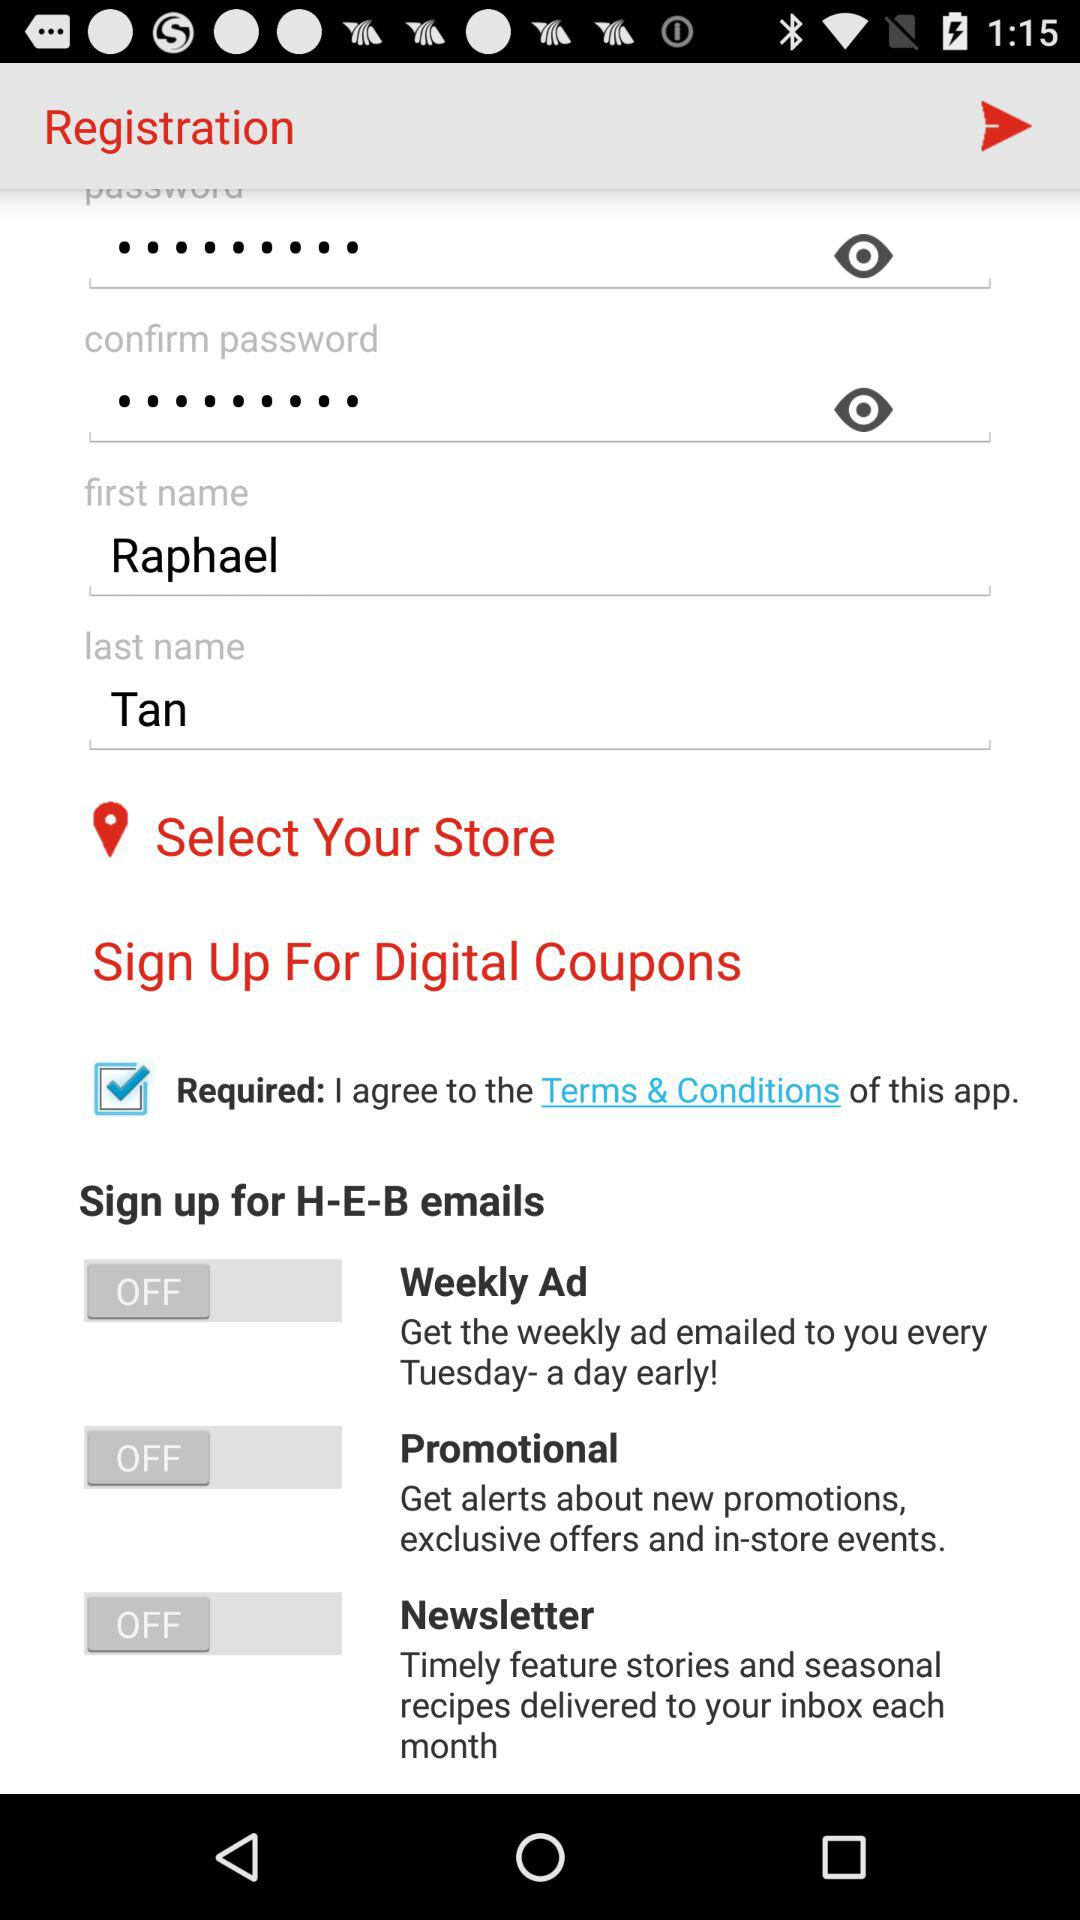How many characters are required for the password?
When the provided information is insufficient, respond with <no answer>. <no answer> 